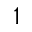Convert formula to latex. <formula><loc_0><loc_0><loc_500><loc_500>^ { 1 }</formula> 